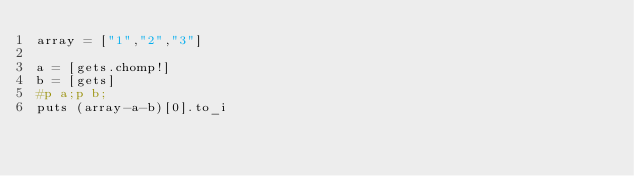Convert code to text. <code><loc_0><loc_0><loc_500><loc_500><_Ruby_>array = ["1","2","3"]

a = [gets.chomp!]
b = [gets]
#p a;p b;
puts (array-a-b)[0].to_i

</code> 